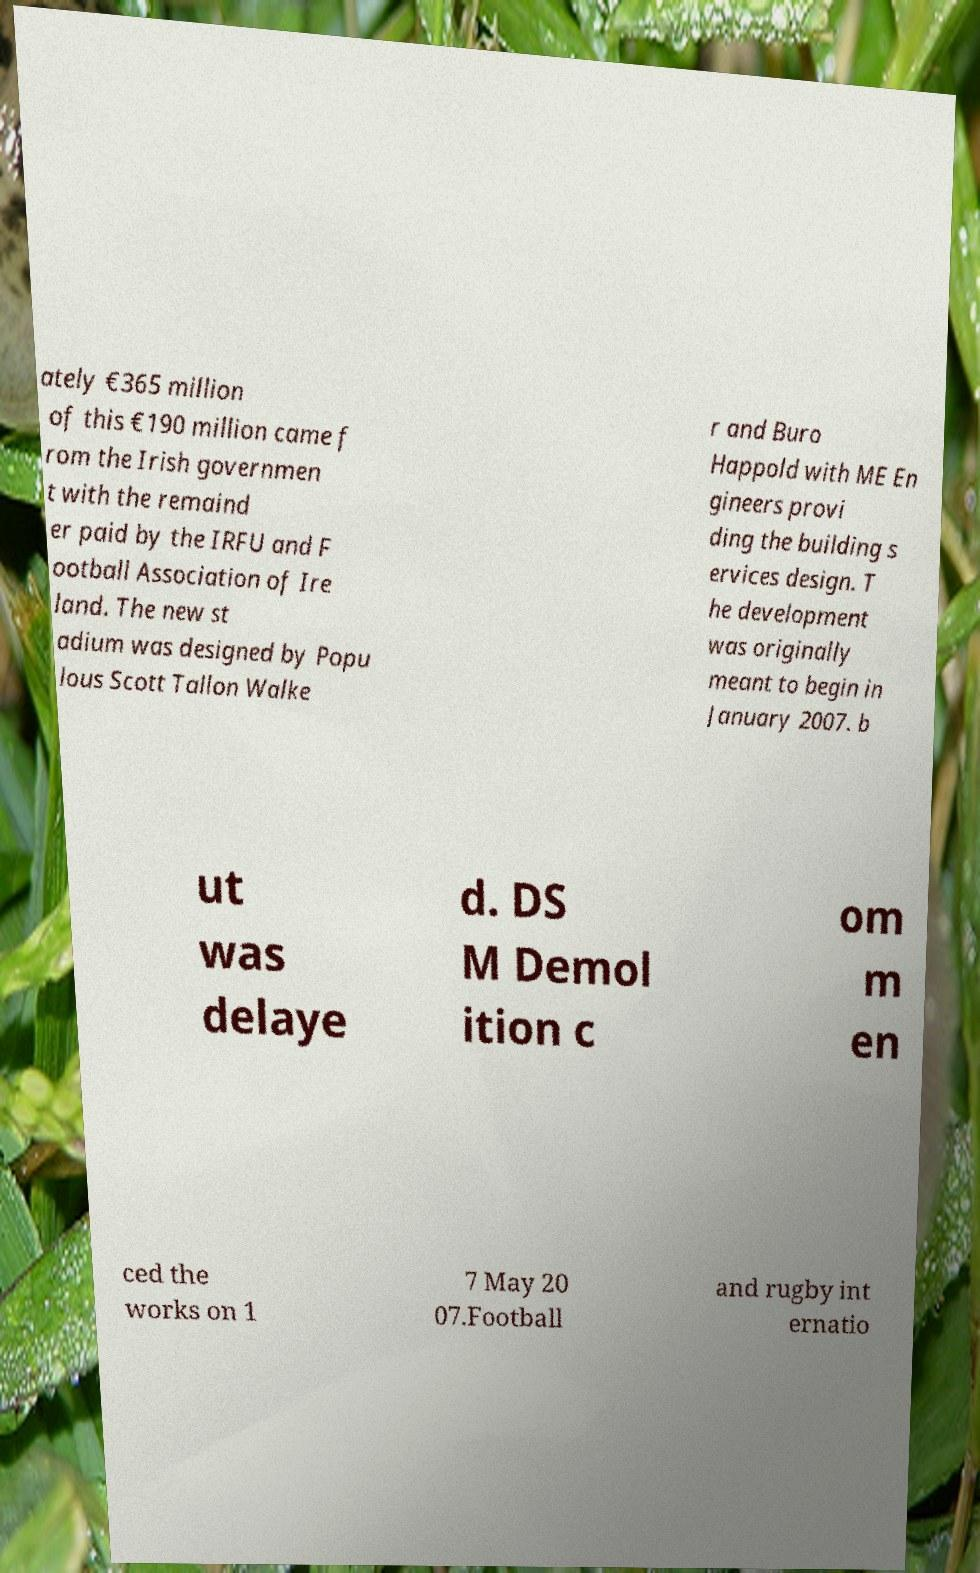Please identify and transcribe the text found in this image. ately €365 million of this €190 million came f rom the Irish governmen t with the remaind er paid by the IRFU and F ootball Association of Ire land. The new st adium was designed by Popu lous Scott Tallon Walke r and Buro Happold with ME En gineers provi ding the building s ervices design. T he development was originally meant to begin in January 2007. b ut was delaye d. DS M Demol ition c om m en ced the works on 1 7 May 20 07.Football and rugby int ernatio 